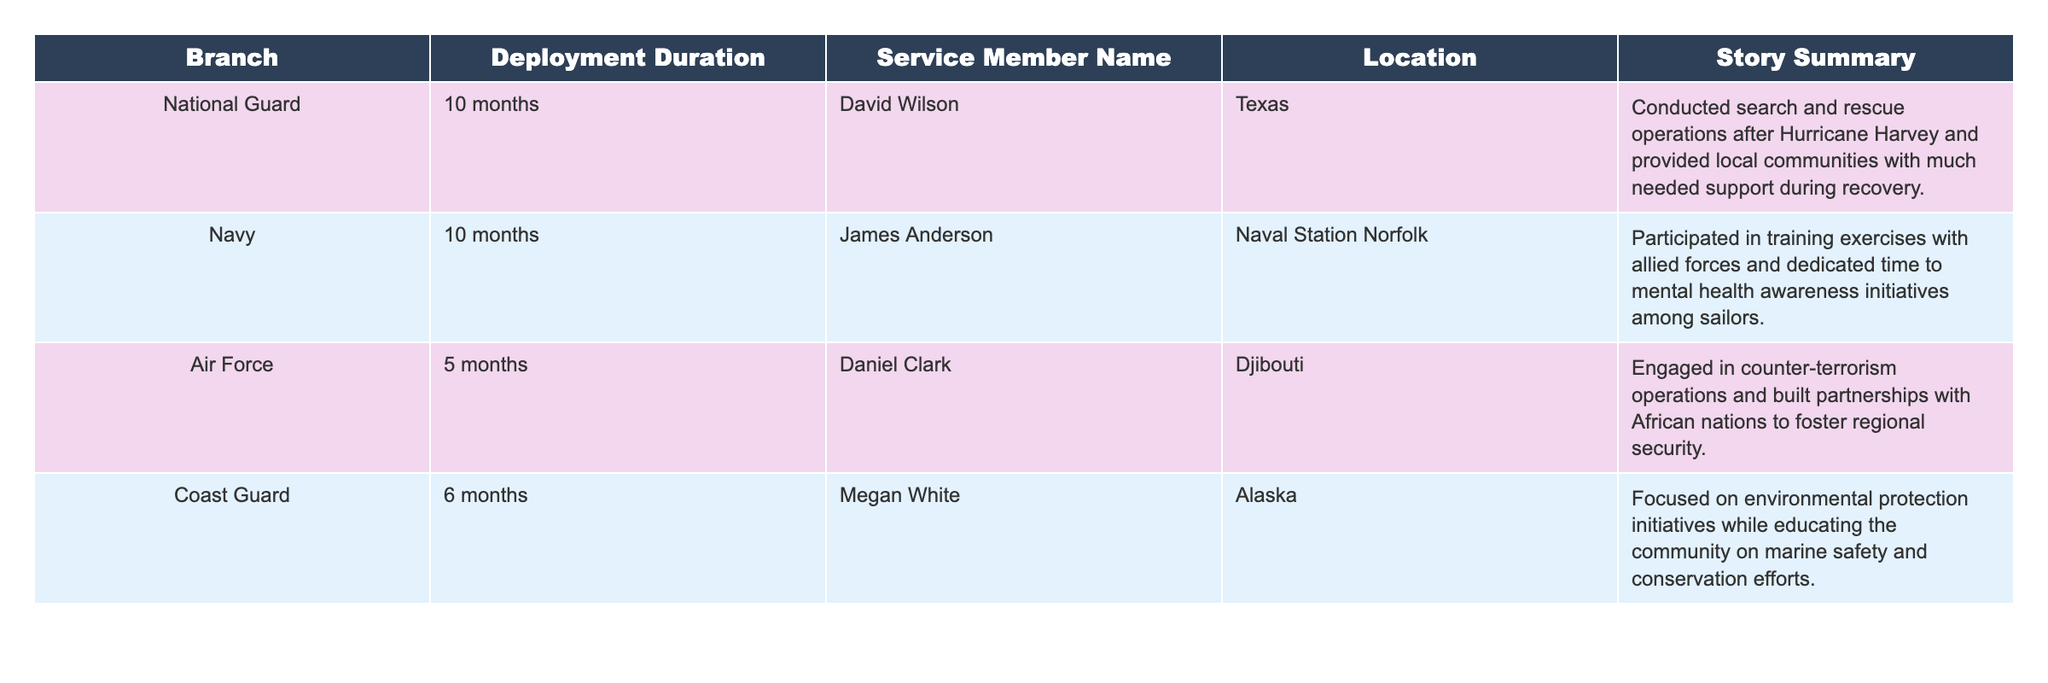What is the total number of service members listed in the table? The table lists four service members: David Wilson, James Anderson, Daniel Clark, and Megan White. Counting these names gives a total of 4 service members.
Answer: 4 What branch did Daniel Clark serve in during his deployment? According to the table, Daniel Clark served in the Air Force. This information is directly retrieved from the "Branch" column corresponding to his name.
Answer: Air Force What is the average deployment duration of the service members listed? The deployment durations are 10 months, 10 months, 5 months, and 6 months. Adding these durations gives a total of 31 months. Dividing by the number of service members (4) gives an average of 31/4 = 7.75 months.
Answer: 7.75 months Which service member had the shortest deployment duration? The service members had deployment durations of 10, 10, 5, and 6 months. The shortest duration is 5 months, which corresponds to Daniel Clark. Thus, he is the service member with the shortest deployment.
Answer: Daniel Clark Did any of the service members participate in environmental protection initiatives? The table shows that Megan White, who served in the Coast Guard, focused on environmental protection initiatives, indicating that the answer is yes.
Answer: Yes Which location had a service member engaged in counter-terrorism operations? The table informs that Daniel Clark, serving in the Air Force, was engaged in counter-terrorism operations in Djibouti. Hence, Djibouti is the corresponding location.
Answer: Djibouti Which branch had the highest duration of deployment among the listed service members? The branches and durations are: National Guard (10 months), Navy (10 months), Air Force (5 months), Coast Guard (6 months). Here, both the National Guard and Navy had the highest durations of 10 months.
Answer: National Guard and Navy Is it true that all service members had deployments longer than 5 months? The table shows deployment durations of 10 months (National Guard), 10 months (Navy), 5 months (Air Force), and 6 months (Coast Guard). Since Daniel Clark had a deployment of exactly 5 months, the answer is no.
Answer: No Which service member provided local communities with support during recovery efforts? From the table, David Wilson from the National Guard conducted search and rescue operations after Hurricane Harvey, which involved supporting local communities.
Answer: David Wilson If you combine the deployment durations of the Navy and Coast Guard, what is the total? The Navy's deployment duration is 10 months and the Coast Guard's duration is 6 months. Adding these gives 10 + 6 = 16 months as the total.
Answer: 16 months 